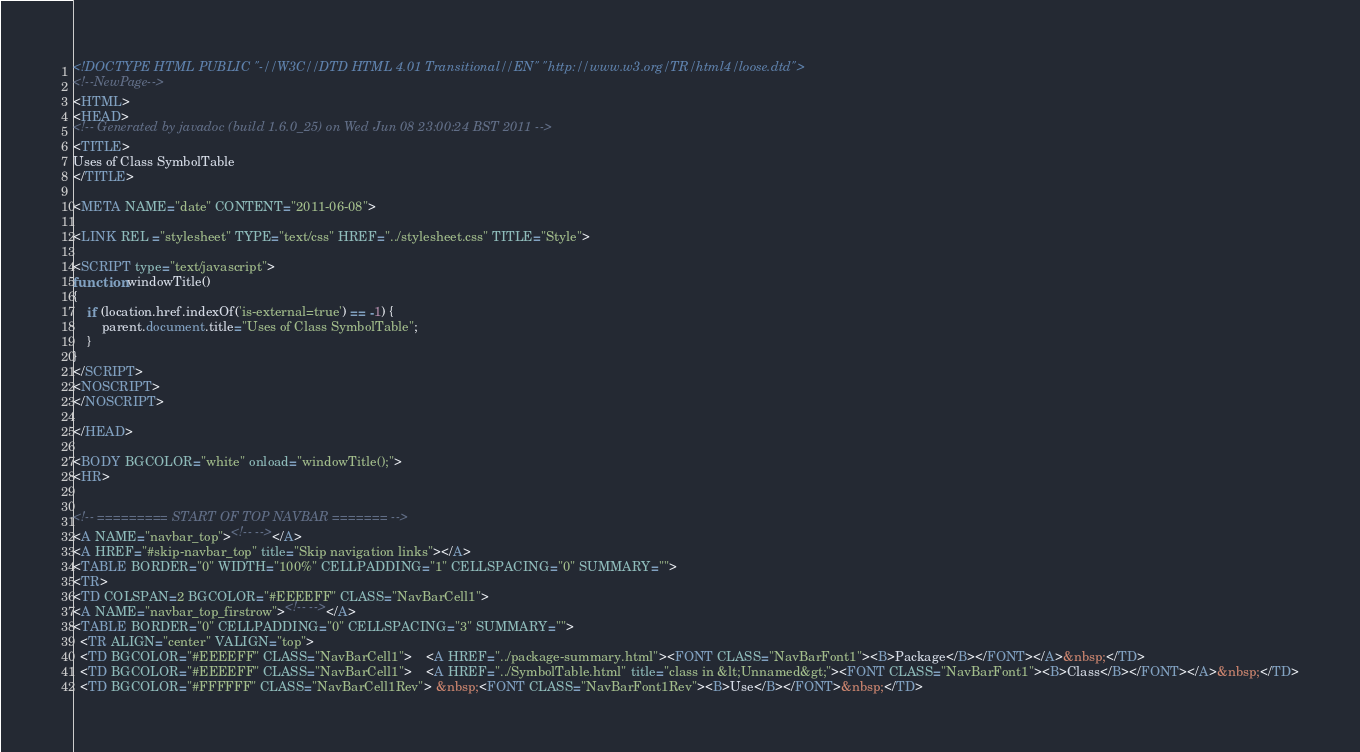<code> <loc_0><loc_0><loc_500><loc_500><_HTML_><!DOCTYPE HTML PUBLIC "-//W3C//DTD HTML 4.01 Transitional//EN" "http://www.w3.org/TR/html4/loose.dtd">
<!--NewPage-->
<HTML>
<HEAD>
<!-- Generated by javadoc (build 1.6.0_25) on Wed Jun 08 23:00:24 BST 2011 -->
<TITLE>
Uses of Class SymbolTable
</TITLE>

<META NAME="date" CONTENT="2011-06-08">

<LINK REL ="stylesheet" TYPE="text/css" HREF="../stylesheet.css" TITLE="Style">

<SCRIPT type="text/javascript">
function windowTitle()
{
    if (location.href.indexOf('is-external=true') == -1) {
        parent.document.title="Uses of Class SymbolTable";
    }
}
</SCRIPT>
<NOSCRIPT>
</NOSCRIPT>

</HEAD>

<BODY BGCOLOR="white" onload="windowTitle();">
<HR>


<!-- ========= START OF TOP NAVBAR ======= -->
<A NAME="navbar_top"><!-- --></A>
<A HREF="#skip-navbar_top" title="Skip navigation links"></A>
<TABLE BORDER="0" WIDTH="100%" CELLPADDING="1" CELLSPACING="0" SUMMARY="">
<TR>
<TD COLSPAN=2 BGCOLOR="#EEEEFF" CLASS="NavBarCell1">
<A NAME="navbar_top_firstrow"><!-- --></A>
<TABLE BORDER="0" CELLPADDING="0" CELLSPACING="3" SUMMARY="">
  <TR ALIGN="center" VALIGN="top">
  <TD BGCOLOR="#EEEEFF" CLASS="NavBarCell1">    <A HREF="../package-summary.html"><FONT CLASS="NavBarFont1"><B>Package</B></FONT></A>&nbsp;</TD>
  <TD BGCOLOR="#EEEEFF" CLASS="NavBarCell1">    <A HREF="../SymbolTable.html" title="class in &lt;Unnamed&gt;"><FONT CLASS="NavBarFont1"><B>Class</B></FONT></A>&nbsp;</TD>
  <TD BGCOLOR="#FFFFFF" CLASS="NavBarCell1Rev"> &nbsp;<FONT CLASS="NavBarFont1Rev"><B>Use</B></FONT>&nbsp;</TD></code> 